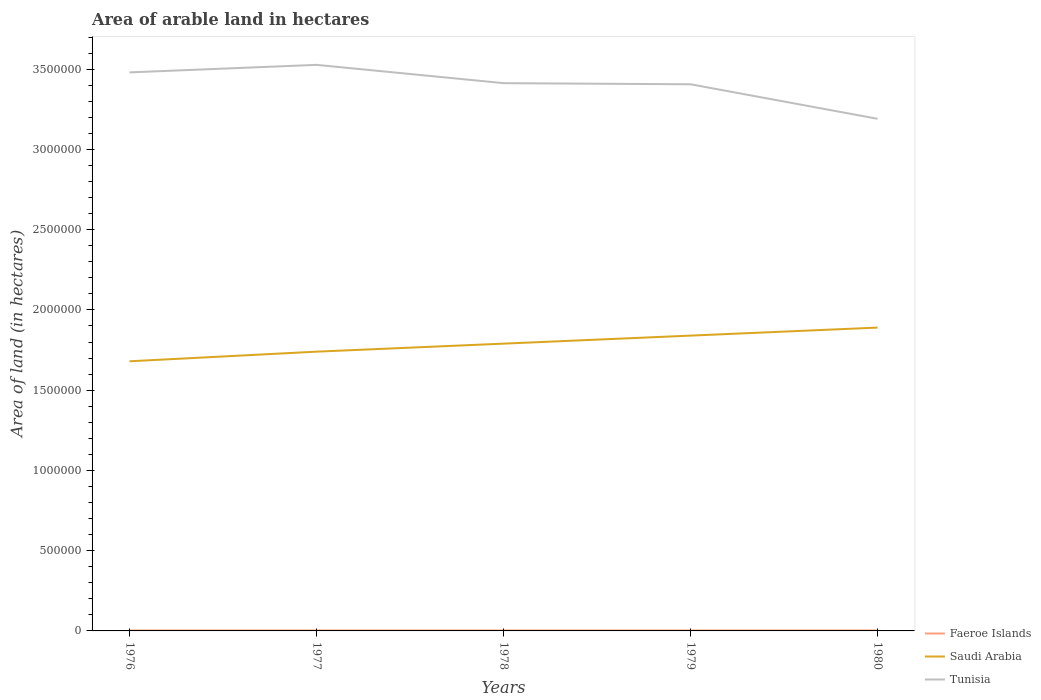Does the line corresponding to Saudi Arabia intersect with the line corresponding to Tunisia?
Provide a succinct answer. No. Is the number of lines equal to the number of legend labels?
Give a very brief answer. Yes. Across all years, what is the maximum total arable land in Saudi Arabia?
Offer a very short reply. 1.68e+06. In which year was the total arable land in Faeroe Islands maximum?
Provide a succinct answer. 1976. What is the total total arable land in Tunisia in the graph?
Ensure brevity in your answer.  1.14e+05. Is the total arable land in Faeroe Islands strictly greater than the total arable land in Tunisia over the years?
Your answer should be very brief. Yes. What is the difference between two consecutive major ticks on the Y-axis?
Provide a succinct answer. 5.00e+05. Are the values on the major ticks of Y-axis written in scientific E-notation?
Offer a terse response. No. Does the graph contain any zero values?
Your answer should be very brief. No. Does the graph contain grids?
Make the answer very short. No. What is the title of the graph?
Give a very brief answer. Area of arable land in hectares. Does "Europe(developing only)" appear as one of the legend labels in the graph?
Offer a very short reply. No. What is the label or title of the Y-axis?
Provide a succinct answer. Area of land (in hectares). What is the Area of land (in hectares) of Faeroe Islands in 1976?
Your answer should be very brief. 3000. What is the Area of land (in hectares) of Saudi Arabia in 1976?
Your answer should be very brief. 1.68e+06. What is the Area of land (in hectares) of Tunisia in 1976?
Offer a terse response. 3.48e+06. What is the Area of land (in hectares) of Faeroe Islands in 1977?
Provide a succinct answer. 3000. What is the Area of land (in hectares) of Saudi Arabia in 1977?
Offer a very short reply. 1.74e+06. What is the Area of land (in hectares) in Tunisia in 1977?
Your response must be concise. 3.53e+06. What is the Area of land (in hectares) in Faeroe Islands in 1978?
Keep it short and to the point. 3000. What is the Area of land (in hectares) in Saudi Arabia in 1978?
Provide a short and direct response. 1.79e+06. What is the Area of land (in hectares) of Tunisia in 1978?
Offer a very short reply. 3.41e+06. What is the Area of land (in hectares) of Faeroe Islands in 1979?
Your answer should be very brief. 3000. What is the Area of land (in hectares) of Saudi Arabia in 1979?
Your answer should be very brief. 1.84e+06. What is the Area of land (in hectares) in Tunisia in 1979?
Your response must be concise. 3.41e+06. What is the Area of land (in hectares) of Faeroe Islands in 1980?
Provide a succinct answer. 3000. What is the Area of land (in hectares) of Saudi Arabia in 1980?
Give a very brief answer. 1.89e+06. What is the Area of land (in hectares) in Tunisia in 1980?
Keep it short and to the point. 3.19e+06. Across all years, what is the maximum Area of land (in hectares) in Faeroe Islands?
Give a very brief answer. 3000. Across all years, what is the maximum Area of land (in hectares) of Saudi Arabia?
Offer a very short reply. 1.89e+06. Across all years, what is the maximum Area of land (in hectares) in Tunisia?
Your answer should be compact. 3.53e+06. Across all years, what is the minimum Area of land (in hectares) in Faeroe Islands?
Your answer should be very brief. 3000. Across all years, what is the minimum Area of land (in hectares) in Saudi Arabia?
Give a very brief answer. 1.68e+06. Across all years, what is the minimum Area of land (in hectares) in Tunisia?
Provide a succinct answer. 3.19e+06. What is the total Area of land (in hectares) in Faeroe Islands in the graph?
Give a very brief answer. 1.50e+04. What is the total Area of land (in hectares) of Saudi Arabia in the graph?
Give a very brief answer. 8.94e+06. What is the total Area of land (in hectares) of Tunisia in the graph?
Keep it short and to the point. 1.70e+07. What is the difference between the Area of land (in hectares) of Faeroe Islands in 1976 and that in 1977?
Provide a short and direct response. 0. What is the difference between the Area of land (in hectares) in Saudi Arabia in 1976 and that in 1977?
Keep it short and to the point. -6.00e+04. What is the difference between the Area of land (in hectares) in Tunisia in 1976 and that in 1977?
Keep it short and to the point. -4.70e+04. What is the difference between the Area of land (in hectares) in Faeroe Islands in 1976 and that in 1978?
Offer a very short reply. 0. What is the difference between the Area of land (in hectares) in Tunisia in 1976 and that in 1978?
Your answer should be compact. 6.70e+04. What is the difference between the Area of land (in hectares) of Faeroe Islands in 1976 and that in 1979?
Make the answer very short. 0. What is the difference between the Area of land (in hectares) in Saudi Arabia in 1976 and that in 1979?
Offer a terse response. -1.60e+05. What is the difference between the Area of land (in hectares) of Tunisia in 1976 and that in 1979?
Offer a very short reply. 7.40e+04. What is the difference between the Area of land (in hectares) of Faeroe Islands in 1976 and that in 1980?
Keep it short and to the point. 0. What is the difference between the Area of land (in hectares) of Saudi Arabia in 1976 and that in 1980?
Keep it short and to the point. -2.10e+05. What is the difference between the Area of land (in hectares) in Tunisia in 1976 and that in 1980?
Offer a very short reply. 2.89e+05. What is the difference between the Area of land (in hectares) of Saudi Arabia in 1977 and that in 1978?
Your answer should be compact. -5.00e+04. What is the difference between the Area of land (in hectares) in Tunisia in 1977 and that in 1978?
Keep it short and to the point. 1.14e+05. What is the difference between the Area of land (in hectares) in Tunisia in 1977 and that in 1979?
Offer a very short reply. 1.21e+05. What is the difference between the Area of land (in hectares) of Faeroe Islands in 1977 and that in 1980?
Provide a succinct answer. 0. What is the difference between the Area of land (in hectares) in Saudi Arabia in 1977 and that in 1980?
Give a very brief answer. -1.50e+05. What is the difference between the Area of land (in hectares) of Tunisia in 1977 and that in 1980?
Your answer should be very brief. 3.36e+05. What is the difference between the Area of land (in hectares) in Tunisia in 1978 and that in 1979?
Make the answer very short. 7000. What is the difference between the Area of land (in hectares) of Faeroe Islands in 1978 and that in 1980?
Keep it short and to the point. 0. What is the difference between the Area of land (in hectares) of Saudi Arabia in 1978 and that in 1980?
Make the answer very short. -1.00e+05. What is the difference between the Area of land (in hectares) in Tunisia in 1978 and that in 1980?
Make the answer very short. 2.22e+05. What is the difference between the Area of land (in hectares) of Tunisia in 1979 and that in 1980?
Provide a short and direct response. 2.15e+05. What is the difference between the Area of land (in hectares) of Faeroe Islands in 1976 and the Area of land (in hectares) of Saudi Arabia in 1977?
Your answer should be very brief. -1.74e+06. What is the difference between the Area of land (in hectares) in Faeroe Islands in 1976 and the Area of land (in hectares) in Tunisia in 1977?
Provide a succinct answer. -3.52e+06. What is the difference between the Area of land (in hectares) in Saudi Arabia in 1976 and the Area of land (in hectares) in Tunisia in 1977?
Your answer should be compact. -1.85e+06. What is the difference between the Area of land (in hectares) of Faeroe Islands in 1976 and the Area of land (in hectares) of Saudi Arabia in 1978?
Provide a succinct answer. -1.79e+06. What is the difference between the Area of land (in hectares) in Faeroe Islands in 1976 and the Area of land (in hectares) in Tunisia in 1978?
Make the answer very short. -3.41e+06. What is the difference between the Area of land (in hectares) of Saudi Arabia in 1976 and the Area of land (in hectares) of Tunisia in 1978?
Provide a succinct answer. -1.73e+06. What is the difference between the Area of land (in hectares) of Faeroe Islands in 1976 and the Area of land (in hectares) of Saudi Arabia in 1979?
Offer a terse response. -1.84e+06. What is the difference between the Area of land (in hectares) in Faeroe Islands in 1976 and the Area of land (in hectares) in Tunisia in 1979?
Make the answer very short. -3.40e+06. What is the difference between the Area of land (in hectares) in Saudi Arabia in 1976 and the Area of land (in hectares) in Tunisia in 1979?
Your answer should be compact. -1.73e+06. What is the difference between the Area of land (in hectares) of Faeroe Islands in 1976 and the Area of land (in hectares) of Saudi Arabia in 1980?
Provide a succinct answer. -1.89e+06. What is the difference between the Area of land (in hectares) of Faeroe Islands in 1976 and the Area of land (in hectares) of Tunisia in 1980?
Provide a succinct answer. -3.19e+06. What is the difference between the Area of land (in hectares) in Saudi Arabia in 1976 and the Area of land (in hectares) in Tunisia in 1980?
Provide a succinct answer. -1.51e+06. What is the difference between the Area of land (in hectares) in Faeroe Islands in 1977 and the Area of land (in hectares) in Saudi Arabia in 1978?
Your answer should be very brief. -1.79e+06. What is the difference between the Area of land (in hectares) in Faeroe Islands in 1977 and the Area of land (in hectares) in Tunisia in 1978?
Make the answer very short. -3.41e+06. What is the difference between the Area of land (in hectares) of Saudi Arabia in 1977 and the Area of land (in hectares) of Tunisia in 1978?
Make the answer very short. -1.67e+06. What is the difference between the Area of land (in hectares) in Faeroe Islands in 1977 and the Area of land (in hectares) in Saudi Arabia in 1979?
Make the answer very short. -1.84e+06. What is the difference between the Area of land (in hectares) in Faeroe Islands in 1977 and the Area of land (in hectares) in Tunisia in 1979?
Your response must be concise. -3.40e+06. What is the difference between the Area of land (in hectares) in Saudi Arabia in 1977 and the Area of land (in hectares) in Tunisia in 1979?
Ensure brevity in your answer.  -1.67e+06. What is the difference between the Area of land (in hectares) in Faeroe Islands in 1977 and the Area of land (in hectares) in Saudi Arabia in 1980?
Your response must be concise. -1.89e+06. What is the difference between the Area of land (in hectares) in Faeroe Islands in 1977 and the Area of land (in hectares) in Tunisia in 1980?
Give a very brief answer. -3.19e+06. What is the difference between the Area of land (in hectares) of Saudi Arabia in 1977 and the Area of land (in hectares) of Tunisia in 1980?
Offer a terse response. -1.45e+06. What is the difference between the Area of land (in hectares) of Faeroe Islands in 1978 and the Area of land (in hectares) of Saudi Arabia in 1979?
Your answer should be very brief. -1.84e+06. What is the difference between the Area of land (in hectares) of Faeroe Islands in 1978 and the Area of land (in hectares) of Tunisia in 1979?
Your answer should be compact. -3.40e+06. What is the difference between the Area of land (in hectares) in Saudi Arabia in 1978 and the Area of land (in hectares) in Tunisia in 1979?
Provide a short and direct response. -1.62e+06. What is the difference between the Area of land (in hectares) of Faeroe Islands in 1978 and the Area of land (in hectares) of Saudi Arabia in 1980?
Provide a short and direct response. -1.89e+06. What is the difference between the Area of land (in hectares) of Faeroe Islands in 1978 and the Area of land (in hectares) of Tunisia in 1980?
Provide a succinct answer. -3.19e+06. What is the difference between the Area of land (in hectares) of Saudi Arabia in 1978 and the Area of land (in hectares) of Tunisia in 1980?
Make the answer very short. -1.40e+06. What is the difference between the Area of land (in hectares) of Faeroe Islands in 1979 and the Area of land (in hectares) of Saudi Arabia in 1980?
Ensure brevity in your answer.  -1.89e+06. What is the difference between the Area of land (in hectares) in Faeroe Islands in 1979 and the Area of land (in hectares) in Tunisia in 1980?
Your answer should be compact. -3.19e+06. What is the difference between the Area of land (in hectares) of Saudi Arabia in 1979 and the Area of land (in hectares) of Tunisia in 1980?
Offer a very short reply. -1.35e+06. What is the average Area of land (in hectares) of Faeroe Islands per year?
Keep it short and to the point. 3000. What is the average Area of land (in hectares) of Saudi Arabia per year?
Ensure brevity in your answer.  1.79e+06. What is the average Area of land (in hectares) in Tunisia per year?
Give a very brief answer. 3.40e+06. In the year 1976, what is the difference between the Area of land (in hectares) of Faeroe Islands and Area of land (in hectares) of Saudi Arabia?
Make the answer very short. -1.68e+06. In the year 1976, what is the difference between the Area of land (in hectares) of Faeroe Islands and Area of land (in hectares) of Tunisia?
Your answer should be very brief. -3.48e+06. In the year 1976, what is the difference between the Area of land (in hectares) in Saudi Arabia and Area of land (in hectares) in Tunisia?
Provide a succinct answer. -1.80e+06. In the year 1977, what is the difference between the Area of land (in hectares) of Faeroe Islands and Area of land (in hectares) of Saudi Arabia?
Provide a short and direct response. -1.74e+06. In the year 1977, what is the difference between the Area of land (in hectares) in Faeroe Islands and Area of land (in hectares) in Tunisia?
Your answer should be compact. -3.52e+06. In the year 1977, what is the difference between the Area of land (in hectares) in Saudi Arabia and Area of land (in hectares) in Tunisia?
Offer a very short reply. -1.79e+06. In the year 1978, what is the difference between the Area of land (in hectares) of Faeroe Islands and Area of land (in hectares) of Saudi Arabia?
Offer a terse response. -1.79e+06. In the year 1978, what is the difference between the Area of land (in hectares) in Faeroe Islands and Area of land (in hectares) in Tunisia?
Your response must be concise. -3.41e+06. In the year 1978, what is the difference between the Area of land (in hectares) in Saudi Arabia and Area of land (in hectares) in Tunisia?
Give a very brief answer. -1.62e+06. In the year 1979, what is the difference between the Area of land (in hectares) in Faeroe Islands and Area of land (in hectares) in Saudi Arabia?
Ensure brevity in your answer.  -1.84e+06. In the year 1979, what is the difference between the Area of land (in hectares) in Faeroe Islands and Area of land (in hectares) in Tunisia?
Make the answer very short. -3.40e+06. In the year 1979, what is the difference between the Area of land (in hectares) in Saudi Arabia and Area of land (in hectares) in Tunisia?
Offer a terse response. -1.57e+06. In the year 1980, what is the difference between the Area of land (in hectares) of Faeroe Islands and Area of land (in hectares) of Saudi Arabia?
Make the answer very short. -1.89e+06. In the year 1980, what is the difference between the Area of land (in hectares) of Faeroe Islands and Area of land (in hectares) of Tunisia?
Ensure brevity in your answer.  -3.19e+06. In the year 1980, what is the difference between the Area of land (in hectares) in Saudi Arabia and Area of land (in hectares) in Tunisia?
Provide a short and direct response. -1.30e+06. What is the ratio of the Area of land (in hectares) in Saudi Arabia in 1976 to that in 1977?
Offer a terse response. 0.97. What is the ratio of the Area of land (in hectares) of Tunisia in 1976 to that in 1977?
Make the answer very short. 0.99. What is the ratio of the Area of land (in hectares) in Faeroe Islands in 1976 to that in 1978?
Ensure brevity in your answer.  1. What is the ratio of the Area of land (in hectares) in Saudi Arabia in 1976 to that in 1978?
Offer a very short reply. 0.94. What is the ratio of the Area of land (in hectares) in Tunisia in 1976 to that in 1978?
Provide a succinct answer. 1.02. What is the ratio of the Area of land (in hectares) of Tunisia in 1976 to that in 1979?
Your response must be concise. 1.02. What is the ratio of the Area of land (in hectares) of Saudi Arabia in 1976 to that in 1980?
Give a very brief answer. 0.89. What is the ratio of the Area of land (in hectares) in Tunisia in 1976 to that in 1980?
Your answer should be very brief. 1.09. What is the ratio of the Area of land (in hectares) of Saudi Arabia in 1977 to that in 1978?
Provide a succinct answer. 0.97. What is the ratio of the Area of land (in hectares) of Tunisia in 1977 to that in 1978?
Give a very brief answer. 1.03. What is the ratio of the Area of land (in hectares) of Saudi Arabia in 1977 to that in 1979?
Your response must be concise. 0.95. What is the ratio of the Area of land (in hectares) in Tunisia in 1977 to that in 1979?
Make the answer very short. 1.04. What is the ratio of the Area of land (in hectares) in Saudi Arabia in 1977 to that in 1980?
Provide a succinct answer. 0.92. What is the ratio of the Area of land (in hectares) of Tunisia in 1977 to that in 1980?
Offer a terse response. 1.11. What is the ratio of the Area of land (in hectares) in Faeroe Islands in 1978 to that in 1979?
Give a very brief answer. 1. What is the ratio of the Area of land (in hectares) in Saudi Arabia in 1978 to that in 1979?
Offer a terse response. 0.97. What is the ratio of the Area of land (in hectares) in Saudi Arabia in 1978 to that in 1980?
Give a very brief answer. 0.95. What is the ratio of the Area of land (in hectares) of Tunisia in 1978 to that in 1980?
Your answer should be compact. 1.07. What is the ratio of the Area of land (in hectares) in Faeroe Islands in 1979 to that in 1980?
Offer a terse response. 1. What is the ratio of the Area of land (in hectares) of Saudi Arabia in 1979 to that in 1980?
Ensure brevity in your answer.  0.97. What is the ratio of the Area of land (in hectares) in Tunisia in 1979 to that in 1980?
Give a very brief answer. 1.07. What is the difference between the highest and the second highest Area of land (in hectares) of Tunisia?
Your answer should be compact. 4.70e+04. What is the difference between the highest and the lowest Area of land (in hectares) of Faeroe Islands?
Offer a terse response. 0. What is the difference between the highest and the lowest Area of land (in hectares) in Saudi Arabia?
Keep it short and to the point. 2.10e+05. What is the difference between the highest and the lowest Area of land (in hectares) in Tunisia?
Provide a succinct answer. 3.36e+05. 